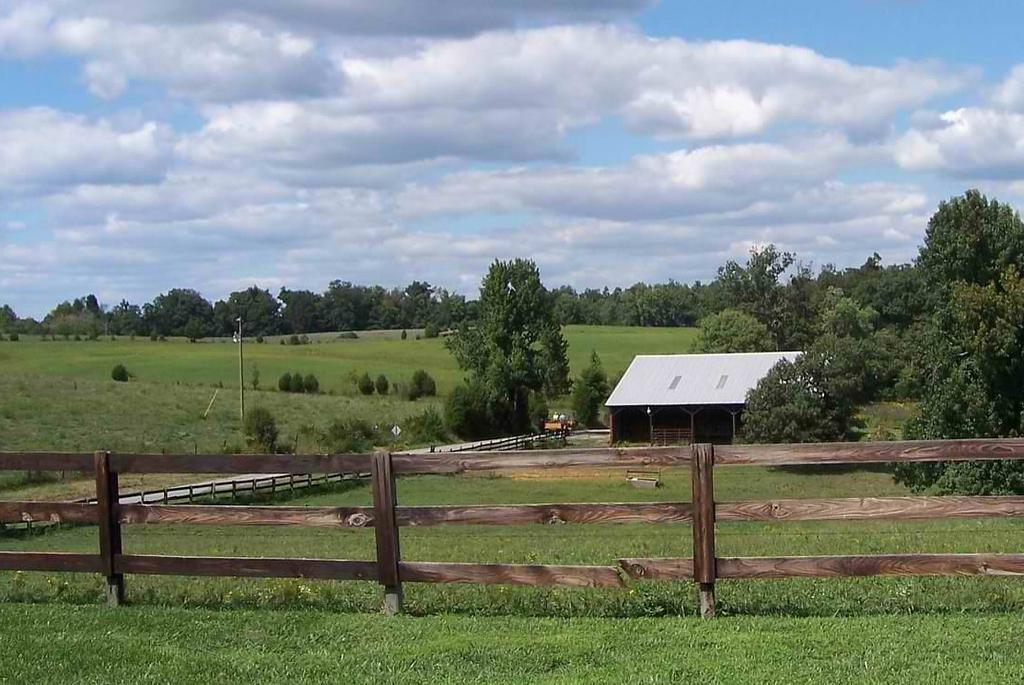What type of barrier can be seen in the image? There is a wooden fence in the image. What type of structure is present in the image? There is a house in the image. What type of vegetation is visible in the image? There are trees, plants, and grass in the image. What part of the natural environment is visible in the image? The sky is visible in the background of the image. Can you tell me how many times your uncle has attempted to grow plants in the image? There is no reference to an uncle or any attempts to grow plants in the image; it simply shows a wooden fence, a house, trees, plants, grass, and the sky. 